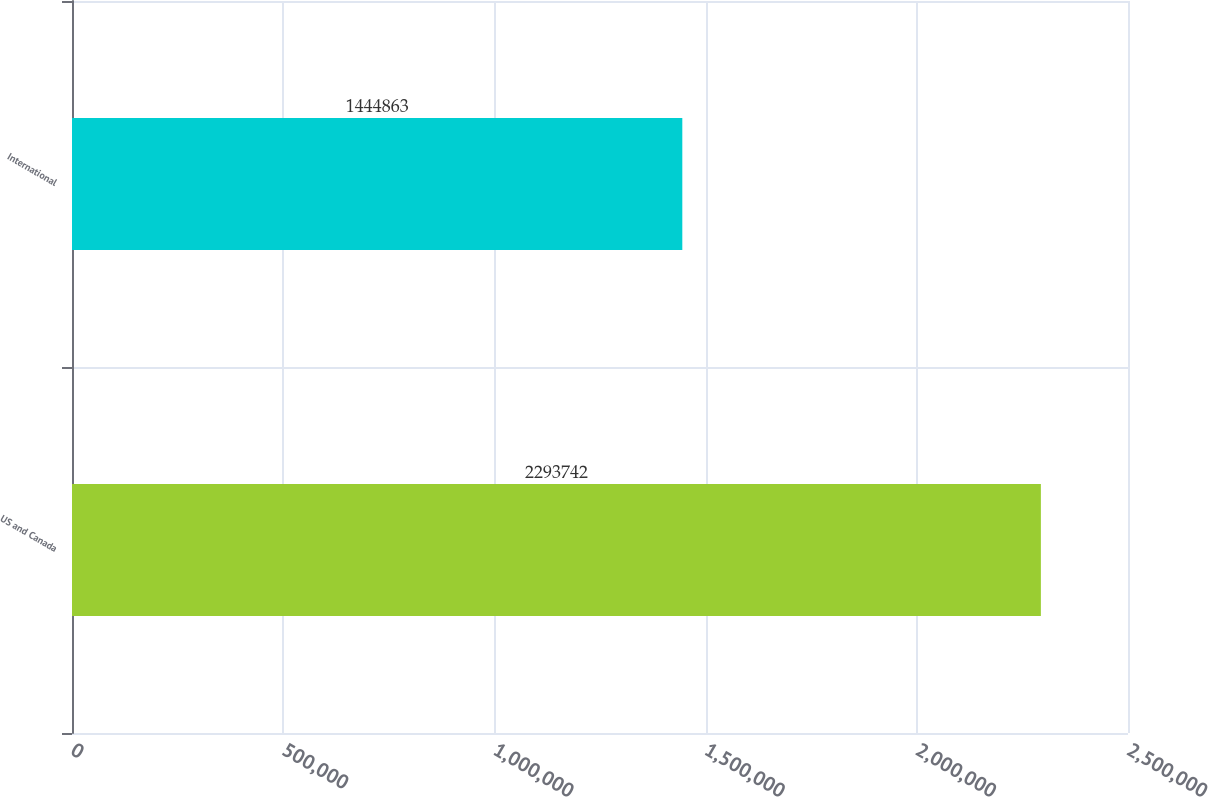Convert chart. <chart><loc_0><loc_0><loc_500><loc_500><bar_chart><fcel>US and Canada<fcel>International<nl><fcel>2.29374e+06<fcel>1.44486e+06<nl></chart> 